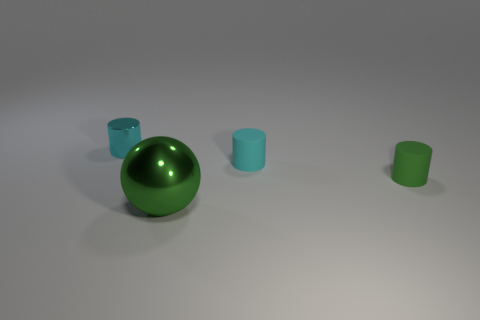Subtract all tiny cyan metallic cylinders. How many cylinders are left? 2 Add 4 big metal objects. How many objects exist? 8 Subtract 1 balls. How many balls are left? 0 Subtract all purple cubes. How many cyan cylinders are left? 2 Subtract all green cylinders. How many cylinders are left? 2 Subtract all cylinders. How many objects are left? 1 Add 4 small rubber objects. How many small rubber objects are left? 6 Add 3 tiny matte cylinders. How many tiny matte cylinders exist? 5 Subtract 0 blue balls. How many objects are left? 4 Subtract all yellow cylinders. Subtract all green cubes. How many cylinders are left? 3 